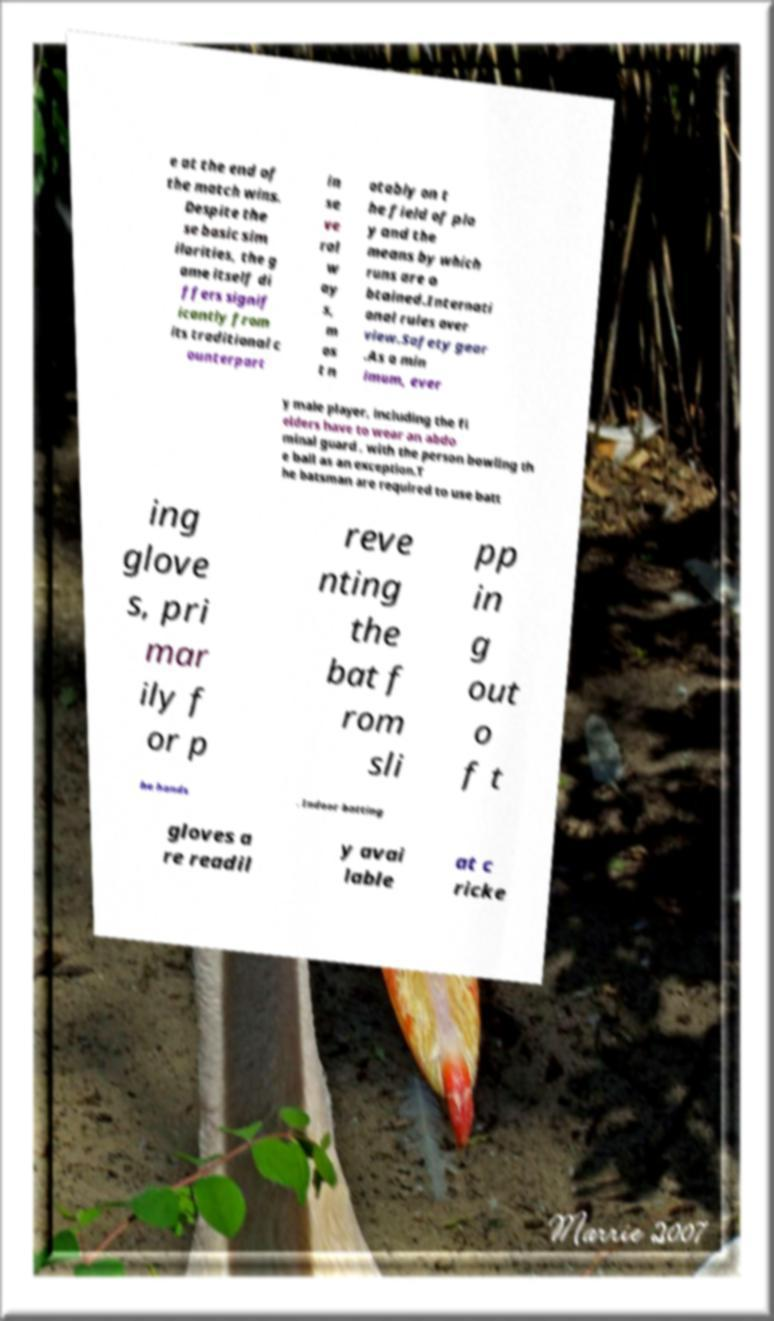For documentation purposes, I need the text within this image transcribed. Could you provide that? e at the end of the match wins. Despite the se basic sim ilarities, the g ame itself di ffers signif icantly from its traditional c ounterpart in se ve ral w ay s, m os t n otably on t he field of pla y and the means by which runs are o btained.Internati onal rules over view.Safety gear .As a min imum, ever y male player, including the fi elders have to wear an abdo minal guard , with the person bowling th e ball as an exception.T he batsman are required to use batt ing glove s, pri mar ily f or p reve nting the bat f rom sli pp in g out o f t he hands . Indoor batting gloves a re readil y avai lable at c ricke 